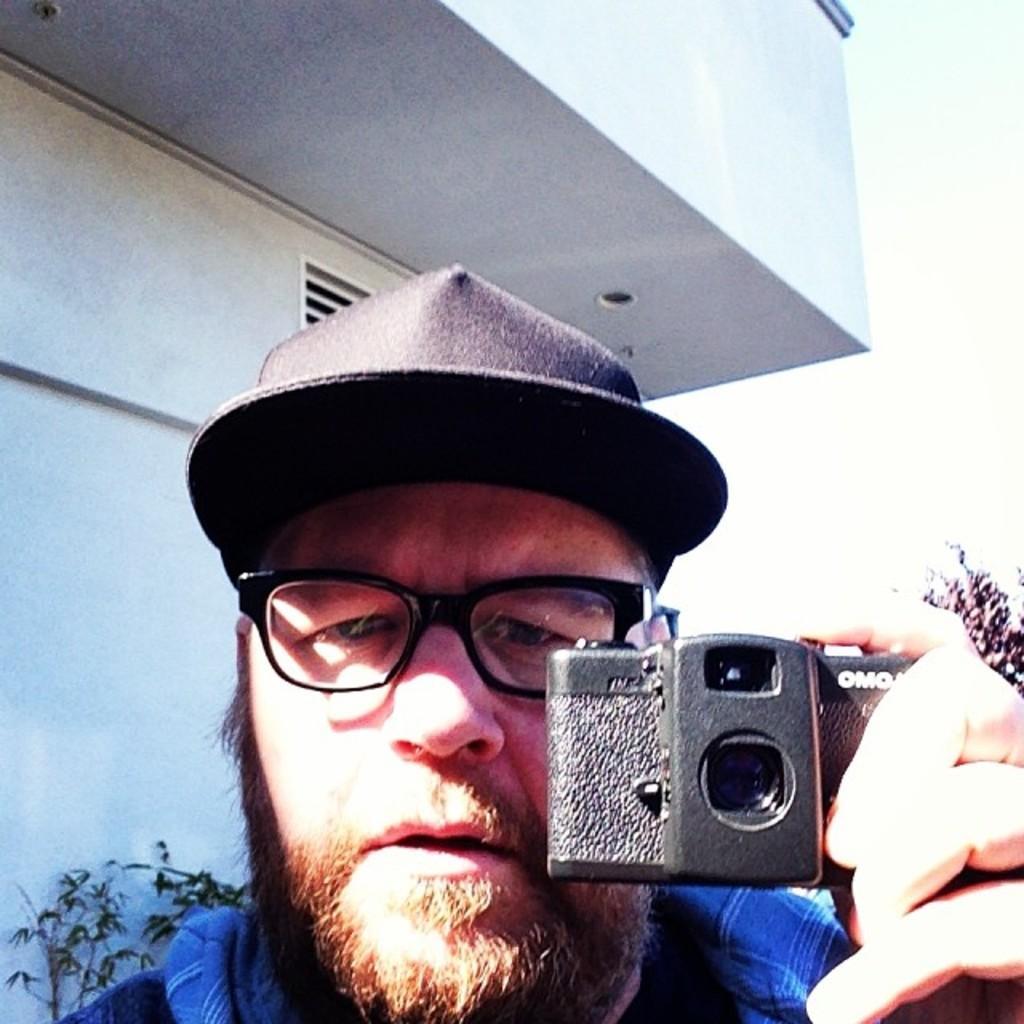Describe this image in one or two sentences. This picture shows a man holds a camera in his hand and we see a building back of him. 